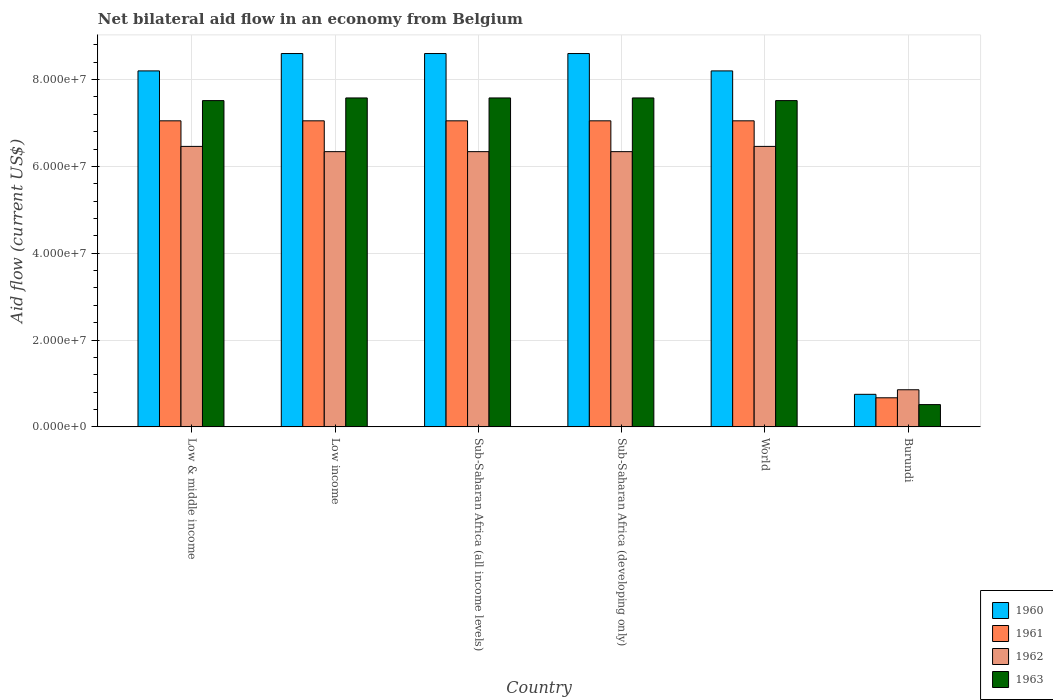How many different coloured bars are there?
Your response must be concise. 4. How many groups of bars are there?
Offer a very short reply. 6. Are the number of bars per tick equal to the number of legend labels?
Your answer should be compact. Yes. Are the number of bars on each tick of the X-axis equal?
Give a very brief answer. Yes. In how many cases, is the number of bars for a given country not equal to the number of legend labels?
Offer a terse response. 0. What is the net bilateral aid flow in 1963 in World?
Keep it short and to the point. 7.52e+07. Across all countries, what is the maximum net bilateral aid flow in 1962?
Your answer should be very brief. 6.46e+07. Across all countries, what is the minimum net bilateral aid flow in 1960?
Provide a short and direct response. 7.50e+06. In which country was the net bilateral aid flow in 1960 maximum?
Provide a short and direct response. Low income. In which country was the net bilateral aid flow in 1961 minimum?
Your response must be concise. Burundi. What is the total net bilateral aid flow in 1963 in the graph?
Offer a very short reply. 3.83e+08. What is the difference between the net bilateral aid flow in 1963 in Sub-Saharan Africa (all income levels) and that in World?
Keep it short and to the point. 6.10e+05. What is the difference between the net bilateral aid flow in 1961 in Burundi and the net bilateral aid flow in 1962 in Low income?
Your answer should be compact. -5.67e+07. What is the average net bilateral aid flow in 1962 per country?
Make the answer very short. 5.47e+07. What is the difference between the net bilateral aid flow of/in 1963 and net bilateral aid flow of/in 1962 in Sub-Saharan Africa (all income levels)?
Your answer should be very brief. 1.24e+07. What is the ratio of the net bilateral aid flow in 1960 in Burundi to that in Low & middle income?
Ensure brevity in your answer.  0.09. Is the net bilateral aid flow in 1960 in Low income less than that in Sub-Saharan Africa (developing only)?
Make the answer very short. No. What is the difference between the highest and the second highest net bilateral aid flow in 1962?
Your answer should be compact. 1.21e+06. What is the difference between the highest and the lowest net bilateral aid flow in 1960?
Provide a succinct answer. 7.85e+07. In how many countries, is the net bilateral aid flow in 1961 greater than the average net bilateral aid flow in 1961 taken over all countries?
Provide a succinct answer. 5. Is the sum of the net bilateral aid flow in 1960 in Burundi and Low income greater than the maximum net bilateral aid flow in 1961 across all countries?
Keep it short and to the point. Yes. Is it the case that in every country, the sum of the net bilateral aid flow in 1963 and net bilateral aid flow in 1962 is greater than the sum of net bilateral aid flow in 1960 and net bilateral aid flow in 1961?
Give a very brief answer. No. What does the 3rd bar from the right in Burundi represents?
Provide a succinct answer. 1961. Are all the bars in the graph horizontal?
Your answer should be very brief. No. Are the values on the major ticks of Y-axis written in scientific E-notation?
Provide a succinct answer. Yes. Does the graph contain any zero values?
Provide a succinct answer. No. Where does the legend appear in the graph?
Offer a very short reply. Bottom right. How many legend labels are there?
Make the answer very short. 4. What is the title of the graph?
Provide a short and direct response. Net bilateral aid flow in an economy from Belgium. What is the label or title of the X-axis?
Make the answer very short. Country. What is the label or title of the Y-axis?
Ensure brevity in your answer.  Aid flow (current US$). What is the Aid flow (current US$) of 1960 in Low & middle income?
Your response must be concise. 8.20e+07. What is the Aid flow (current US$) in 1961 in Low & middle income?
Make the answer very short. 7.05e+07. What is the Aid flow (current US$) in 1962 in Low & middle income?
Give a very brief answer. 6.46e+07. What is the Aid flow (current US$) in 1963 in Low & middle income?
Your answer should be compact. 7.52e+07. What is the Aid flow (current US$) in 1960 in Low income?
Give a very brief answer. 8.60e+07. What is the Aid flow (current US$) of 1961 in Low income?
Give a very brief answer. 7.05e+07. What is the Aid flow (current US$) in 1962 in Low income?
Provide a short and direct response. 6.34e+07. What is the Aid flow (current US$) in 1963 in Low income?
Give a very brief answer. 7.58e+07. What is the Aid flow (current US$) of 1960 in Sub-Saharan Africa (all income levels)?
Keep it short and to the point. 8.60e+07. What is the Aid flow (current US$) of 1961 in Sub-Saharan Africa (all income levels)?
Your answer should be compact. 7.05e+07. What is the Aid flow (current US$) in 1962 in Sub-Saharan Africa (all income levels)?
Ensure brevity in your answer.  6.34e+07. What is the Aid flow (current US$) of 1963 in Sub-Saharan Africa (all income levels)?
Offer a very short reply. 7.58e+07. What is the Aid flow (current US$) in 1960 in Sub-Saharan Africa (developing only)?
Your answer should be compact. 8.60e+07. What is the Aid flow (current US$) of 1961 in Sub-Saharan Africa (developing only)?
Make the answer very short. 7.05e+07. What is the Aid flow (current US$) of 1962 in Sub-Saharan Africa (developing only)?
Your answer should be compact. 6.34e+07. What is the Aid flow (current US$) of 1963 in Sub-Saharan Africa (developing only)?
Offer a very short reply. 7.58e+07. What is the Aid flow (current US$) of 1960 in World?
Your answer should be very brief. 8.20e+07. What is the Aid flow (current US$) of 1961 in World?
Offer a terse response. 7.05e+07. What is the Aid flow (current US$) in 1962 in World?
Provide a short and direct response. 6.46e+07. What is the Aid flow (current US$) in 1963 in World?
Ensure brevity in your answer.  7.52e+07. What is the Aid flow (current US$) in 1960 in Burundi?
Give a very brief answer. 7.50e+06. What is the Aid flow (current US$) in 1961 in Burundi?
Provide a short and direct response. 6.70e+06. What is the Aid flow (current US$) in 1962 in Burundi?
Your response must be concise. 8.55e+06. What is the Aid flow (current US$) of 1963 in Burundi?
Offer a very short reply. 5.13e+06. Across all countries, what is the maximum Aid flow (current US$) of 1960?
Offer a terse response. 8.60e+07. Across all countries, what is the maximum Aid flow (current US$) of 1961?
Make the answer very short. 7.05e+07. Across all countries, what is the maximum Aid flow (current US$) in 1962?
Keep it short and to the point. 6.46e+07. Across all countries, what is the maximum Aid flow (current US$) in 1963?
Provide a short and direct response. 7.58e+07. Across all countries, what is the minimum Aid flow (current US$) in 1960?
Make the answer very short. 7.50e+06. Across all countries, what is the minimum Aid flow (current US$) of 1961?
Your response must be concise. 6.70e+06. Across all countries, what is the minimum Aid flow (current US$) of 1962?
Make the answer very short. 8.55e+06. Across all countries, what is the minimum Aid flow (current US$) in 1963?
Your answer should be compact. 5.13e+06. What is the total Aid flow (current US$) in 1960 in the graph?
Give a very brief answer. 4.30e+08. What is the total Aid flow (current US$) in 1961 in the graph?
Provide a succinct answer. 3.59e+08. What is the total Aid flow (current US$) of 1962 in the graph?
Provide a short and direct response. 3.28e+08. What is the total Aid flow (current US$) in 1963 in the graph?
Give a very brief answer. 3.83e+08. What is the difference between the Aid flow (current US$) in 1961 in Low & middle income and that in Low income?
Your response must be concise. 0. What is the difference between the Aid flow (current US$) in 1962 in Low & middle income and that in Low income?
Offer a terse response. 1.21e+06. What is the difference between the Aid flow (current US$) in 1963 in Low & middle income and that in Low income?
Provide a succinct answer. -6.10e+05. What is the difference between the Aid flow (current US$) of 1960 in Low & middle income and that in Sub-Saharan Africa (all income levels)?
Ensure brevity in your answer.  -4.00e+06. What is the difference between the Aid flow (current US$) in 1961 in Low & middle income and that in Sub-Saharan Africa (all income levels)?
Ensure brevity in your answer.  0. What is the difference between the Aid flow (current US$) in 1962 in Low & middle income and that in Sub-Saharan Africa (all income levels)?
Make the answer very short. 1.21e+06. What is the difference between the Aid flow (current US$) in 1963 in Low & middle income and that in Sub-Saharan Africa (all income levels)?
Ensure brevity in your answer.  -6.10e+05. What is the difference between the Aid flow (current US$) in 1962 in Low & middle income and that in Sub-Saharan Africa (developing only)?
Ensure brevity in your answer.  1.21e+06. What is the difference between the Aid flow (current US$) in 1963 in Low & middle income and that in Sub-Saharan Africa (developing only)?
Your answer should be compact. -6.10e+05. What is the difference between the Aid flow (current US$) in 1960 in Low & middle income and that in World?
Offer a very short reply. 0. What is the difference between the Aid flow (current US$) in 1960 in Low & middle income and that in Burundi?
Your answer should be very brief. 7.45e+07. What is the difference between the Aid flow (current US$) in 1961 in Low & middle income and that in Burundi?
Offer a terse response. 6.38e+07. What is the difference between the Aid flow (current US$) in 1962 in Low & middle income and that in Burundi?
Your answer should be very brief. 5.61e+07. What is the difference between the Aid flow (current US$) of 1963 in Low & middle income and that in Burundi?
Your answer should be compact. 7.00e+07. What is the difference between the Aid flow (current US$) in 1960 in Low income and that in Sub-Saharan Africa (all income levels)?
Ensure brevity in your answer.  0. What is the difference between the Aid flow (current US$) of 1961 in Low income and that in Sub-Saharan Africa (all income levels)?
Provide a short and direct response. 0. What is the difference between the Aid flow (current US$) of 1962 in Low income and that in Sub-Saharan Africa (all income levels)?
Offer a very short reply. 0. What is the difference between the Aid flow (current US$) in 1963 in Low income and that in Sub-Saharan Africa (all income levels)?
Provide a short and direct response. 0. What is the difference between the Aid flow (current US$) in 1960 in Low income and that in Sub-Saharan Africa (developing only)?
Make the answer very short. 0. What is the difference between the Aid flow (current US$) in 1961 in Low income and that in Sub-Saharan Africa (developing only)?
Your response must be concise. 0. What is the difference between the Aid flow (current US$) of 1962 in Low income and that in Sub-Saharan Africa (developing only)?
Keep it short and to the point. 0. What is the difference between the Aid flow (current US$) of 1963 in Low income and that in Sub-Saharan Africa (developing only)?
Give a very brief answer. 0. What is the difference between the Aid flow (current US$) in 1960 in Low income and that in World?
Offer a very short reply. 4.00e+06. What is the difference between the Aid flow (current US$) of 1961 in Low income and that in World?
Give a very brief answer. 0. What is the difference between the Aid flow (current US$) in 1962 in Low income and that in World?
Offer a very short reply. -1.21e+06. What is the difference between the Aid flow (current US$) of 1963 in Low income and that in World?
Your answer should be very brief. 6.10e+05. What is the difference between the Aid flow (current US$) of 1960 in Low income and that in Burundi?
Your response must be concise. 7.85e+07. What is the difference between the Aid flow (current US$) in 1961 in Low income and that in Burundi?
Offer a terse response. 6.38e+07. What is the difference between the Aid flow (current US$) in 1962 in Low income and that in Burundi?
Keep it short and to the point. 5.48e+07. What is the difference between the Aid flow (current US$) of 1963 in Low income and that in Burundi?
Offer a terse response. 7.06e+07. What is the difference between the Aid flow (current US$) of 1960 in Sub-Saharan Africa (all income levels) and that in Sub-Saharan Africa (developing only)?
Offer a very short reply. 0. What is the difference between the Aid flow (current US$) of 1961 in Sub-Saharan Africa (all income levels) and that in Sub-Saharan Africa (developing only)?
Make the answer very short. 0. What is the difference between the Aid flow (current US$) of 1962 in Sub-Saharan Africa (all income levels) and that in Sub-Saharan Africa (developing only)?
Keep it short and to the point. 0. What is the difference between the Aid flow (current US$) of 1963 in Sub-Saharan Africa (all income levels) and that in Sub-Saharan Africa (developing only)?
Your answer should be very brief. 0. What is the difference between the Aid flow (current US$) of 1962 in Sub-Saharan Africa (all income levels) and that in World?
Offer a very short reply. -1.21e+06. What is the difference between the Aid flow (current US$) in 1963 in Sub-Saharan Africa (all income levels) and that in World?
Your response must be concise. 6.10e+05. What is the difference between the Aid flow (current US$) of 1960 in Sub-Saharan Africa (all income levels) and that in Burundi?
Provide a succinct answer. 7.85e+07. What is the difference between the Aid flow (current US$) in 1961 in Sub-Saharan Africa (all income levels) and that in Burundi?
Offer a very short reply. 6.38e+07. What is the difference between the Aid flow (current US$) of 1962 in Sub-Saharan Africa (all income levels) and that in Burundi?
Offer a very short reply. 5.48e+07. What is the difference between the Aid flow (current US$) in 1963 in Sub-Saharan Africa (all income levels) and that in Burundi?
Provide a succinct answer. 7.06e+07. What is the difference between the Aid flow (current US$) in 1962 in Sub-Saharan Africa (developing only) and that in World?
Provide a short and direct response. -1.21e+06. What is the difference between the Aid flow (current US$) of 1963 in Sub-Saharan Africa (developing only) and that in World?
Provide a short and direct response. 6.10e+05. What is the difference between the Aid flow (current US$) of 1960 in Sub-Saharan Africa (developing only) and that in Burundi?
Your answer should be very brief. 7.85e+07. What is the difference between the Aid flow (current US$) in 1961 in Sub-Saharan Africa (developing only) and that in Burundi?
Provide a short and direct response. 6.38e+07. What is the difference between the Aid flow (current US$) in 1962 in Sub-Saharan Africa (developing only) and that in Burundi?
Ensure brevity in your answer.  5.48e+07. What is the difference between the Aid flow (current US$) in 1963 in Sub-Saharan Africa (developing only) and that in Burundi?
Give a very brief answer. 7.06e+07. What is the difference between the Aid flow (current US$) of 1960 in World and that in Burundi?
Provide a succinct answer. 7.45e+07. What is the difference between the Aid flow (current US$) of 1961 in World and that in Burundi?
Keep it short and to the point. 6.38e+07. What is the difference between the Aid flow (current US$) in 1962 in World and that in Burundi?
Provide a short and direct response. 5.61e+07. What is the difference between the Aid flow (current US$) in 1963 in World and that in Burundi?
Provide a succinct answer. 7.00e+07. What is the difference between the Aid flow (current US$) in 1960 in Low & middle income and the Aid flow (current US$) in 1961 in Low income?
Provide a succinct answer. 1.15e+07. What is the difference between the Aid flow (current US$) of 1960 in Low & middle income and the Aid flow (current US$) of 1962 in Low income?
Provide a succinct answer. 1.86e+07. What is the difference between the Aid flow (current US$) in 1960 in Low & middle income and the Aid flow (current US$) in 1963 in Low income?
Ensure brevity in your answer.  6.23e+06. What is the difference between the Aid flow (current US$) in 1961 in Low & middle income and the Aid flow (current US$) in 1962 in Low income?
Ensure brevity in your answer.  7.10e+06. What is the difference between the Aid flow (current US$) of 1961 in Low & middle income and the Aid flow (current US$) of 1963 in Low income?
Give a very brief answer. -5.27e+06. What is the difference between the Aid flow (current US$) in 1962 in Low & middle income and the Aid flow (current US$) in 1963 in Low income?
Ensure brevity in your answer.  -1.12e+07. What is the difference between the Aid flow (current US$) of 1960 in Low & middle income and the Aid flow (current US$) of 1961 in Sub-Saharan Africa (all income levels)?
Ensure brevity in your answer.  1.15e+07. What is the difference between the Aid flow (current US$) in 1960 in Low & middle income and the Aid flow (current US$) in 1962 in Sub-Saharan Africa (all income levels)?
Offer a terse response. 1.86e+07. What is the difference between the Aid flow (current US$) of 1960 in Low & middle income and the Aid flow (current US$) of 1963 in Sub-Saharan Africa (all income levels)?
Provide a succinct answer. 6.23e+06. What is the difference between the Aid flow (current US$) of 1961 in Low & middle income and the Aid flow (current US$) of 1962 in Sub-Saharan Africa (all income levels)?
Your response must be concise. 7.10e+06. What is the difference between the Aid flow (current US$) in 1961 in Low & middle income and the Aid flow (current US$) in 1963 in Sub-Saharan Africa (all income levels)?
Make the answer very short. -5.27e+06. What is the difference between the Aid flow (current US$) of 1962 in Low & middle income and the Aid flow (current US$) of 1963 in Sub-Saharan Africa (all income levels)?
Your answer should be compact. -1.12e+07. What is the difference between the Aid flow (current US$) of 1960 in Low & middle income and the Aid flow (current US$) of 1961 in Sub-Saharan Africa (developing only)?
Provide a succinct answer. 1.15e+07. What is the difference between the Aid flow (current US$) in 1960 in Low & middle income and the Aid flow (current US$) in 1962 in Sub-Saharan Africa (developing only)?
Provide a succinct answer. 1.86e+07. What is the difference between the Aid flow (current US$) of 1960 in Low & middle income and the Aid flow (current US$) of 1963 in Sub-Saharan Africa (developing only)?
Your answer should be very brief. 6.23e+06. What is the difference between the Aid flow (current US$) in 1961 in Low & middle income and the Aid flow (current US$) in 1962 in Sub-Saharan Africa (developing only)?
Your answer should be very brief. 7.10e+06. What is the difference between the Aid flow (current US$) of 1961 in Low & middle income and the Aid flow (current US$) of 1963 in Sub-Saharan Africa (developing only)?
Give a very brief answer. -5.27e+06. What is the difference between the Aid flow (current US$) of 1962 in Low & middle income and the Aid flow (current US$) of 1963 in Sub-Saharan Africa (developing only)?
Your answer should be very brief. -1.12e+07. What is the difference between the Aid flow (current US$) in 1960 in Low & middle income and the Aid flow (current US$) in 1961 in World?
Make the answer very short. 1.15e+07. What is the difference between the Aid flow (current US$) in 1960 in Low & middle income and the Aid flow (current US$) in 1962 in World?
Provide a succinct answer. 1.74e+07. What is the difference between the Aid flow (current US$) of 1960 in Low & middle income and the Aid flow (current US$) of 1963 in World?
Offer a very short reply. 6.84e+06. What is the difference between the Aid flow (current US$) of 1961 in Low & middle income and the Aid flow (current US$) of 1962 in World?
Offer a very short reply. 5.89e+06. What is the difference between the Aid flow (current US$) of 1961 in Low & middle income and the Aid flow (current US$) of 1963 in World?
Your answer should be compact. -4.66e+06. What is the difference between the Aid flow (current US$) of 1962 in Low & middle income and the Aid flow (current US$) of 1963 in World?
Your answer should be very brief. -1.06e+07. What is the difference between the Aid flow (current US$) in 1960 in Low & middle income and the Aid flow (current US$) in 1961 in Burundi?
Give a very brief answer. 7.53e+07. What is the difference between the Aid flow (current US$) of 1960 in Low & middle income and the Aid flow (current US$) of 1962 in Burundi?
Ensure brevity in your answer.  7.34e+07. What is the difference between the Aid flow (current US$) of 1960 in Low & middle income and the Aid flow (current US$) of 1963 in Burundi?
Ensure brevity in your answer.  7.69e+07. What is the difference between the Aid flow (current US$) in 1961 in Low & middle income and the Aid flow (current US$) in 1962 in Burundi?
Your response must be concise. 6.20e+07. What is the difference between the Aid flow (current US$) of 1961 in Low & middle income and the Aid flow (current US$) of 1963 in Burundi?
Offer a terse response. 6.54e+07. What is the difference between the Aid flow (current US$) in 1962 in Low & middle income and the Aid flow (current US$) in 1963 in Burundi?
Give a very brief answer. 5.95e+07. What is the difference between the Aid flow (current US$) of 1960 in Low income and the Aid flow (current US$) of 1961 in Sub-Saharan Africa (all income levels)?
Ensure brevity in your answer.  1.55e+07. What is the difference between the Aid flow (current US$) in 1960 in Low income and the Aid flow (current US$) in 1962 in Sub-Saharan Africa (all income levels)?
Ensure brevity in your answer.  2.26e+07. What is the difference between the Aid flow (current US$) of 1960 in Low income and the Aid flow (current US$) of 1963 in Sub-Saharan Africa (all income levels)?
Your answer should be very brief. 1.02e+07. What is the difference between the Aid flow (current US$) of 1961 in Low income and the Aid flow (current US$) of 1962 in Sub-Saharan Africa (all income levels)?
Your answer should be compact. 7.10e+06. What is the difference between the Aid flow (current US$) of 1961 in Low income and the Aid flow (current US$) of 1963 in Sub-Saharan Africa (all income levels)?
Make the answer very short. -5.27e+06. What is the difference between the Aid flow (current US$) in 1962 in Low income and the Aid flow (current US$) in 1963 in Sub-Saharan Africa (all income levels)?
Provide a short and direct response. -1.24e+07. What is the difference between the Aid flow (current US$) in 1960 in Low income and the Aid flow (current US$) in 1961 in Sub-Saharan Africa (developing only)?
Your response must be concise. 1.55e+07. What is the difference between the Aid flow (current US$) of 1960 in Low income and the Aid flow (current US$) of 1962 in Sub-Saharan Africa (developing only)?
Ensure brevity in your answer.  2.26e+07. What is the difference between the Aid flow (current US$) of 1960 in Low income and the Aid flow (current US$) of 1963 in Sub-Saharan Africa (developing only)?
Your answer should be compact. 1.02e+07. What is the difference between the Aid flow (current US$) of 1961 in Low income and the Aid flow (current US$) of 1962 in Sub-Saharan Africa (developing only)?
Ensure brevity in your answer.  7.10e+06. What is the difference between the Aid flow (current US$) of 1961 in Low income and the Aid flow (current US$) of 1963 in Sub-Saharan Africa (developing only)?
Provide a short and direct response. -5.27e+06. What is the difference between the Aid flow (current US$) of 1962 in Low income and the Aid flow (current US$) of 1963 in Sub-Saharan Africa (developing only)?
Offer a terse response. -1.24e+07. What is the difference between the Aid flow (current US$) of 1960 in Low income and the Aid flow (current US$) of 1961 in World?
Your response must be concise. 1.55e+07. What is the difference between the Aid flow (current US$) of 1960 in Low income and the Aid flow (current US$) of 1962 in World?
Make the answer very short. 2.14e+07. What is the difference between the Aid flow (current US$) in 1960 in Low income and the Aid flow (current US$) in 1963 in World?
Your answer should be very brief. 1.08e+07. What is the difference between the Aid flow (current US$) of 1961 in Low income and the Aid flow (current US$) of 1962 in World?
Your answer should be very brief. 5.89e+06. What is the difference between the Aid flow (current US$) in 1961 in Low income and the Aid flow (current US$) in 1963 in World?
Ensure brevity in your answer.  -4.66e+06. What is the difference between the Aid flow (current US$) of 1962 in Low income and the Aid flow (current US$) of 1963 in World?
Offer a terse response. -1.18e+07. What is the difference between the Aid flow (current US$) of 1960 in Low income and the Aid flow (current US$) of 1961 in Burundi?
Offer a terse response. 7.93e+07. What is the difference between the Aid flow (current US$) of 1960 in Low income and the Aid flow (current US$) of 1962 in Burundi?
Your answer should be compact. 7.74e+07. What is the difference between the Aid flow (current US$) in 1960 in Low income and the Aid flow (current US$) in 1963 in Burundi?
Your answer should be compact. 8.09e+07. What is the difference between the Aid flow (current US$) in 1961 in Low income and the Aid flow (current US$) in 1962 in Burundi?
Ensure brevity in your answer.  6.20e+07. What is the difference between the Aid flow (current US$) in 1961 in Low income and the Aid flow (current US$) in 1963 in Burundi?
Your response must be concise. 6.54e+07. What is the difference between the Aid flow (current US$) in 1962 in Low income and the Aid flow (current US$) in 1963 in Burundi?
Offer a very short reply. 5.83e+07. What is the difference between the Aid flow (current US$) in 1960 in Sub-Saharan Africa (all income levels) and the Aid flow (current US$) in 1961 in Sub-Saharan Africa (developing only)?
Make the answer very short. 1.55e+07. What is the difference between the Aid flow (current US$) of 1960 in Sub-Saharan Africa (all income levels) and the Aid flow (current US$) of 1962 in Sub-Saharan Africa (developing only)?
Ensure brevity in your answer.  2.26e+07. What is the difference between the Aid flow (current US$) of 1960 in Sub-Saharan Africa (all income levels) and the Aid flow (current US$) of 1963 in Sub-Saharan Africa (developing only)?
Your answer should be compact. 1.02e+07. What is the difference between the Aid flow (current US$) in 1961 in Sub-Saharan Africa (all income levels) and the Aid flow (current US$) in 1962 in Sub-Saharan Africa (developing only)?
Provide a succinct answer. 7.10e+06. What is the difference between the Aid flow (current US$) in 1961 in Sub-Saharan Africa (all income levels) and the Aid flow (current US$) in 1963 in Sub-Saharan Africa (developing only)?
Provide a short and direct response. -5.27e+06. What is the difference between the Aid flow (current US$) in 1962 in Sub-Saharan Africa (all income levels) and the Aid flow (current US$) in 1963 in Sub-Saharan Africa (developing only)?
Offer a terse response. -1.24e+07. What is the difference between the Aid flow (current US$) in 1960 in Sub-Saharan Africa (all income levels) and the Aid flow (current US$) in 1961 in World?
Provide a succinct answer. 1.55e+07. What is the difference between the Aid flow (current US$) of 1960 in Sub-Saharan Africa (all income levels) and the Aid flow (current US$) of 1962 in World?
Provide a succinct answer. 2.14e+07. What is the difference between the Aid flow (current US$) in 1960 in Sub-Saharan Africa (all income levels) and the Aid flow (current US$) in 1963 in World?
Make the answer very short. 1.08e+07. What is the difference between the Aid flow (current US$) of 1961 in Sub-Saharan Africa (all income levels) and the Aid flow (current US$) of 1962 in World?
Give a very brief answer. 5.89e+06. What is the difference between the Aid flow (current US$) in 1961 in Sub-Saharan Africa (all income levels) and the Aid flow (current US$) in 1963 in World?
Your response must be concise. -4.66e+06. What is the difference between the Aid flow (current US$) in 1962 in Sub-Saharan Africa (all income levels) and the Aid flow (current US$) in 1963 in World?
Offer a very short reply. -1.18e+07. What is the difference between the Aid flow (current US$) of 1960 in Sub-Saharan Africa (all income levels) and the Aid flow (current US$) of 1961 in Burundi?
Your answer should be compact. 7.93e+07. What is the difference between the Aid flow (current US$) in 1960 in Sub-Saharan Africa (all income levels) and the Aid flow (current US$) in 1962 in Burundi?
Keep it short and to the point. 7.74e+07. What is the difference between the Aid flow (current US$) of 1960 in Sub-Saharan Africa (all income levels) and the Aid flow (current US$) of 1963 in Burundi?
Keep it short and to the point. 8.09e+07. What is the difference between the Aid flow (current US$) of 1961 in Sub-Saharan Africa (all income levels) and the Aid flow (current US$) of 1962 in Burundi?
Your response must be concise. 6.20e+07. What is the difference between the Aid flow (current US$) of 1961 in Sub-Saharan Africa (all income levels) and the Aid flow (current US$) of 1963 in Burundi?
Offer a very short reply. 6.54e+07. What is the difference between the Aid flow (current US$) in 1962 in Sub-Saharan Africa (all income levels) and the Aid flow (current US$) in 1963 in Burundi?
Offer a very short reply. 5.83e+07. What is the difference between the Aid flow (current US$) of 1960 in Sub-Saharan Africa (developing only) and the Aid flow (current US$) of 1961 in World?
Provide a succinct answer. 1.55e+07. What is the difference between the Aid flow (current US$) in 1960 in Sub-Saharan Africa (developing only) and the Aid flow (current US$) in 1962 in World?
Offer a terse response. 2.14e+07. What is the difference between the Aid flow (current US$) of 1960 in Sub-Saharan Africa (developing only) and the Aid flow (current US$) of 1963 in World?
Provide a succinct answer. 1.08e+07. What is the difference between the Aid flow (current US$) of 1961 in Sub-Saharan Africa (developing only) and the Aid flow (current US$) of 1962 in World?
Your answer should be compact. 5.89e+06. What is the difference between the Aid flow (current US$) in 1961 in Sub-Saharan Africa (developing only) and the Aid flow (current US$) in 1963 in World?
Provide a short and direct response. -4.66e+06. What is the difference between the Aid flow (current US$) of 1962 in Sub-Saharan Africa (developing only) and the Aid flow (current US$) of 1963 in World?
Keep it short and to the point. -1.18e+07. What is the difference between the Aid flow (current US$) in 1960 in Sub-Saharan Africa (developing only) and the Aid flow (current US$) in 1961 in Burundi?
Offer a terse response. 7.93e+07. What is the difference between the Aid flow (current US$) in 1960 in Sub-Saharan Africa (developing only) and the Aid flow (current US$) in 1962 in Burundi?
Provide a succinct answer. 7.74e+07. What is the difference between the Aid flow (current US$) in 1960 in Sub-Saharan Africa (developing only) and the Aid flow (current US$) in 1963 in Burundi?
Your answer should be compact. 8.09e+07. What is the difference between the Aid flow (current US$) of 1961 in Sub-Saharan Africa (developing only) and the Aid flow (current US$) of 1962 in Burundi?
Your answer should be very brief. 6.20e+07. What is the difference between the Aid flow (current US$) in 1961 in Sub-Saharan Africa (developing only) and the Aid flow (current US$) in 1963 in Burundi?
Offer a very short reply. 6.54e+07. What is the difference between the Aid flow (current US$) of 1962 in Sub-Saharan Africa (developing only) and the Aid flow (current US$) of 1963 in Burundi?
Your response must be concise. 5.83e+07. What is the difference between the Aid flow (current US$) of 1960 in World and the Aid flow (current US$) of 1961 in Burundi?
Provide a short and direct response. 7.53e+07. What is the difference between the Aid flow (current US$) of 1960 in World and the Aid flow (current US$) of 1962 in Burundi?
Offer a terse response. 7.34e+07. What is the difference between the Aid flow (current US$) in 1960 in World and the Aid flow (current US$) in 1963 in Burundi?
Your answer should be very brief. 7.69e+07. What is the difference between the Aid flow (current US$) of 1961 in World and the Aid flow (current US$) of 1962 in Burundi?
Make the answer very short. 6.20e+07. What is the difference between the Aid flow (current US$) in 1961 in World and the Aid flow (current US$) in 1963 in Burundi?
Provide a short and direct response. 6.54e+07. What is the difference between the Aid flow (current US$) in 1962 in World and the Aid flow (current US$) in 1963 in Burundi?
Your answer should be very brief. 5.95e+07. What is the average Aid flow (current US$) in 1960 per country?
Your answer should be very brief. 7.16e+07. What is the average Aid flow (current US$) in 1961 per country?
Provide a short and direct response. 5.99e+07. What is the average Aid flow (current US$) of 1962 per country?
Ensure brevity in your answer.  5.47e+07. What is the average Aid flow (current US$) in 1963 per country?
Provide a short and direct response. 6.38e+07. What is the difference between the Aid flow (current US$) in 1960 and Aid flow (current US$) in 1961 in Low & middle income?
Your answer should be compact. 1.15e+07. What is the difference between the Aid flow (current US$) of 1960 and Aid flow (current US$) of 1962 in Low & middle income?
Your response must be concise. 1.74e+07. What is the difference between the Aid flow (current US$) of 1960 and Aid flow (current US$) of 1963 in Low & middle income?
Your answer should be very brief. 6.84e+06. What is the difference between the Aid flow (current US$) in 1961 and Aid flow (current US$) in 1962 in Low & middle income?
Provide a short and direct response. 5.89e+06. What is the difference between the Aid flow (current US$) of 1961 and Aid flow (current US$) of 1963 in Low & middle income?
Make the answer very short. -4.66e+06. What is the difference between the Aid flow (current US$) of 1962 and Aid flow (current US$) of 1963 in Low & middle income?
Provide a short and direct response. -1.06e+07. What is the difference between the Aid flow (current US$) of 1960 and Aid flow (current US$) of 1961 in Low income?
Your response must be concise. 1.55e+07. What is the difference between the Aid flow (current US$) of 1960 and Aid flow (current US$) of 1962 in Low income?
Provide a succinct answer. 2.26e+07. What is the difference between the Aid flow (current US$) of 1960 and Aid flow (current US$) of 1963 in Low income?
Offer a terse response. 1.02e+07. What is the difference between the Aid flow (current US$) of 1961 and Aid flow (current US$) of 1962 in Low income?
Your response must be concise. 7.10e+06. What is the difference between the Aid flow (current US$) in 1961 and Aid flow (current US$) in 1963 in Low income?
Your response must be concise. -5.27e+06. What is the difference between the Aid flow (current US$) in 1962 and Aid flow (current US$) in 1963 in Low income?
Make the answer very short. -1.24e+07. What is the difference between the Aid flow (current US$) in 1960 and Aid flow (current US$) in 1961 in Sub-Saharan Africa (all income levels)?
Provide a short and direct response. 1.55e+07. What is the difference between the Aid flow (current US$) in 1960 and Aid flow (current US$) in 1962 in Sub-Saharan Africa (all income levels)?
Provide a succinct answer. 2.26e+07. What is the difference between the Aid flow (current US$) in 1960 and Aid flow (current US$) in 1963 in Sub-Saharan Africa (all income levels)?
Make the answer very short. 1.02e+07. What is the difference between the Aid flow (current US$) of 1961 and Aid flow (current US$) of 1962 in Sub-Saharan Africa (all income levels)?
Make the answer very short. 7.10e+06. What is the difference between the Aid flow (current US$) of 1961 and Aid flow (current US$) of 1963 in Sub-Saharan Africa (all income levels)?
Provide a succinct answer. -5.27e+06. What is the difference between the Aid flow (current US$) in 1962 and Aid flow (current US$) in 1963 in Sub-Saharan Africa (all income levels)?
Your response must be concise. -1.24e+07. What is the difference between the Aid flow (current US$) in 1960 and Aid flow (current US$) in 1961 in Sub-Saharan Africa (developing only)?
Your response must be concise. 1.55e+07. What is the difference between the Aid flow (current US$) of 1960 and Aid flow (current US$) of 1962 in Sub-Saharan Africa (developing only)?
Your answer should be compact. 2.26e+07. What is the difference between the Aid flow (current US$) in 1960 and Aid flow (current US$) in 1963 in Sub-Saharan Africa (developing only)?
Your response must be concise. 1.02e+07. What is the difference between the Aid flow (current US$) of 1961 and Aid flow (current US$) of 1962 in Sub-Saharan Africa (developing only)?
Your answer should be compact. 7.10e+06. What is the difference between the Aid flow (current US$) in 1961 and Aid flow (current US$) in 1963 in Sub-Saharan Africa (developing only)?
Make the answer very short. -5.27e+06. What is the difference between the Aid flow (current US$) in 1962 and Aid flow (current US$) in 1963 in Sub-Saharan Africa (developing only)?
Your answer should be compact. -1.24e+07. What is the difference between the Aid flow (current US$) in 1960 and Aid flow (current US$) in 1961 in World?
Your response must be concise. 1.15e+07. What is the difference between the Aid flow (current US$) in 1960 and Aid flow (current US$) in 1962 in World?
Your answer should be compact. 1.74e+07. What is the difference between the Aid flow (current US$) of 1960 and Aid flow (current US$) of 1963 in World?
Make the answer very short. 6.84e+06. What is the difference between the Aid flow (current US$) of 1961 and Aid flow (current US$) of 1962 in World?
Make the answer very short. 5.89e+06. What is the difference between the Aid flow (current US$) of 1961 and Aid flow (current US$) of 1963 in World?
Make the answer very short. -4.66e+06. What is the difference between the Aid flow (current US$) of 1962 and Aid flow (current US$) of 1963 in World?
Give a very brief answer. -1.06e+07. What is the difference between the Aid flow (current US$) of 1960 and Aid flow (current US$) of 1961 in Burundi?
Your answer should be compact. 8.00e+05. What is the difference between the Aid flow (current US$) in 1960 and Aid flow (current US$) in 1962 in Burundi?
Ensure brevity in your answer.  -1.05e+06. What is the difference between the Aid flow (current US$) of 1960 and Aid flow (current US$) of 1963 in Burundi?
Your answer should be very brief. 2.37e+06. What is the difference between the Aid flow (current US$) of 1961 and Aid flow (current US$) of 1962 in Burundi?
Offer a very short reply. -1.85e+06. What is the difference between the Aid flow (current US$) in 1961 and Aid flow (current US$) in 1963 in Burundi?
Offer a very short reply. 1.57e+06. What is the difference between the Aid flow (current US$) of 1962 and Aid flow (current US$) of 1963 in Burundi?
Provide a succinct answer. 3.42e+06. What is the ratio of the Aid flow (current US$) in 1960 in Low & middle income to that in Low income?
Your answer should be compact. 0.95. What is the ratio of the Aid flow (current US$) of 1962 in Low & middle income to that in Low income?
Your response must be concise. 1.02. What is the ratio of the Aid flow (current US$) in 1963 in Low & middle income to that in Low income?
Keep it short and to the point. 0.99. What is the ratio of the Aid flow (current US$) in 1960 in Low & middle income to that in Sub-Saharan Africa (all income levels)?
Give a very brief answer. 0.95. What is the ratio of the Aid flow (current US$) in 1961 in Low & middle income to that in Sub-Saharan Africa (all income levels)?
Ensure brevity in your answer.  1. What is the ratio of the Aid flow (current US$) of 1962 in Low & middle income to that in Sub-Saharan Africa (all income levels)?
Offer a very short reply. 1.02. What is the ratio of the Aid flow (current US$) of 1963 in Low & middle income to that in Sub-Saharan Africa (all income levels)?
Offer a terse response. 0.99. What is the ratio of the Aid flow (current US$) in 1960 in Low & middle income to that in Sub-Saharan Africa (developing only)?
Give a very brief answer. 0.95. What is the ratio of the Aid flow (current US$) in 1962 in Low & middle income to that in Sub-Saharan Africa (developing only)?
Provide a short and direct response. 1.02. What is the ratio of the Aid flow (current US$) of 1960 in Low & middle income to that in World?
Offer a terse response. 1. What is the ratio of the Aid flow (current US$) in 1962 in Low & middle income to that in World?
Provide a short and direct response. 1. What is the ratio of the Aid flow (current US$) of 1960 in Low & middle income to that in Burundi?
Your response must be concise. 10.93. What is the ratio of the Aid flow (current US$) in 1961 in Low & middle income to that in Burundi?
Give a very brief answer. 10.52. What is the ratio of the Aid flow (current US$) in 1962 in Low & middle income to that in Burundi?
Your answer should be compact. 7.56. What is the ratio of the Aid flow (current US$) in 1963 in Low & middle income to that in Burundi?
Provide a succinct answer. 14.65. What is the ratio of the Aid flow (current US$) of 1961 in Low income to that in Sub-Saharan Africa (all income levels)?
Your response must be concise. 1. What is the ratio of the Aid flow (current US$) of 1963 in Low income to that in Sub-Saharan Africa (all income levels)?
Your response must be concise. 1. What is the ratio of the Aid flow (current US$) of 1961 in Low income to that in Sub-Saharan Africa (developing only)?
Make the answer very short. 1. What is the ratio of the Aid flow (current US$) in 1963 in Low income to that in Sub-Saharan Africa (developing only)?
Keep it short and to the point. 1. What is the ratio of the Aid flow (current US$) in 1960 in Low income to that in World?
Give a very brief answer. 1.05. What is the ratio of the Aid flow (current US$) in 1962 in Low income to that in World?
Keep it short and to the point. 0.98. What is the ratio of the Aid flow (current US$) of 1960 in Low income to that in Burundi?
Provide a succinct answer. 11.47. What is the ratio of the Aid flow (current US$) in 1961 in Low income to that in Burundi?
Provide a succinct answer. 10.52. What is the ratio of the Aid flow (current US$) in 1962 in Low income to that in Burundi?
Make the answer very short. 7.42. What is the ratio of the Aid flow (current US$) in 1963 in Low income to that in Burundi?
Offer a terse response. 14.77. What is the ratio of the Aid flow (current US$) of 1961 in Sub-Saharan Africa (all income levels) to that in Sub-Saharan Africa (developing only)?
Offer a terse response. 1. What is the ratio of the Aid flow (current US$) of 1960 in Sub-Saharan Africa (all income levels) to that in World?
Your response must be concise. 1.05. What is the ratio of the Aid flow (current US$) of 1961 in Sub-Saharan Africa (all income levels) to that in World?
Provide a succinct answer. 1. What is the ratio of the Aid flow (current US$) of 1962 in Sub-Saharan Africa (all income levels) to that in World?
Your answer should be very brief. 0.98. What is the ratio of the Aid flow (current US$) of 1963 in Sub-Saharan Africa (all income levels) to that in World?
Give a very brief answer. 1.01. What is the ratio of the Aid flow (current US$) in 1960 in Sub-Saharan Africa (all income levels) to that in Burundi?
Offer a terse response. 11.47. What is the ratio of the Aid flow (current US$) of 1961 in Sub-Saharan Africa (all income levels) to that in Burundi?
Provide a succinct answer. 10.52. What is the ratio of the Aid flow (current US$) of 1962 in Sub-Saharan Africa (all income levels) to that in Burundi?
Offer a terse response. 7.42. What is the ratio of the Aid flow (current US$) of 1963 in Sub-Saharan Africa (all income levels) to that in Burundi?
Offer a terse response. 14.77. What is the ratio of the Aid flow (current US$) in 1960 in Sub-Saharan Africa (developing only) to that in World?
Your response must be concise. 1.05. What is the ratio of the Aid flow (current US$) in 1961 in Sub-Saharan Africa (developing only) to that in World?
Provide a succinct answer. 1. What is the ratio of the Aid flow (current US$) of 1962 in Sub-Saharan Africa (developing only) to that in World?
Provide a succinct answer. 0.98. What is the ratio of the Aid flow (current US$) of 1960 in Sub-Saharan Africa (developing only) to that in Burundi?
Your answer should be very brief. 11.47. What is the ratio of the Aid flow (current US$) in 1961 in Sub-Saharan Africa (developing only) to that in Burundi?
Give a very brief answer. 10.52. What is the ratio of the Aid flow (current US$) of 1962 in Sub-Saharan Africa (developing only) to that in Burundi?
Provide a short and direct response. 7.42. What is the ratio of the Aid flow (current US$) of 1963 in Sub-Saharan Africa (developing only) to that in Burundi?
Your answer should be compact. 14.77. What is the ratio of the Aid flow (current US$) in 1960 in World to that in Burundi?
Offer a terse response. 10.93. What is the ratio of the Aid flow (current US$) in 1961 in World to that in Burundi?
Make the answer very short. 10.52. What is the ratio of the Aid flow (current US$) of 1962 in World to that in Burundi?
Keep it short and to the point. 7.56. What is the ratio of the Aid flow (current US$) in 1963 in World to that in Burundi?
Your answer should be very brief. 14.65. What is the difference between the highest and the second highest Aid flow (current US$) of 1960?
Ensure brevity in your answer.  0. What is the difference between the highest and the lowest Aid flow (current US$) in 1960?
Make the answer very short. 7.85e+07. What is the difference between the highest and the lowest Aid flow (current US$) of 1961?
Your answer should be very brief. 6.38e+07. What is the difference between the highest and the lowest Aid flow (current US$) of 1962?
Make the answer very short. 5.61e+07. What is the difference between the highest and the lowest Aid flow (current US$) of 1963?
Offer a terse response. 7.06e+07. 